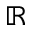Convert formula to latex. <formula><loc_0><loc_0><loc_500><loc_500>\mathbb { R }</formula> 